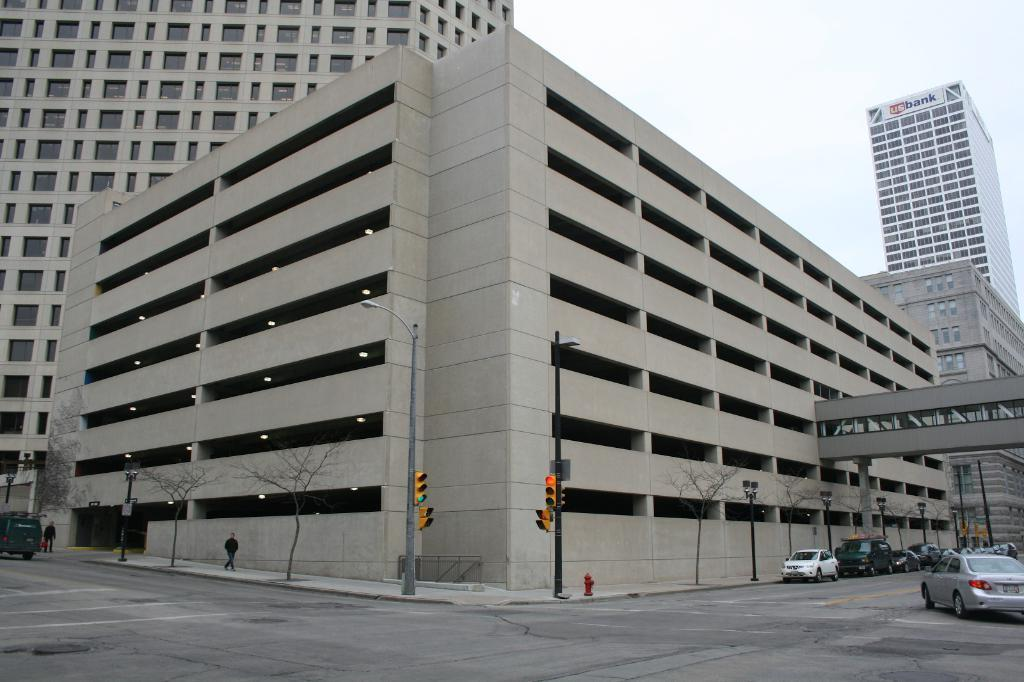What type of structures can be seen in the image? There are buildings in the image. What kind of vegetation is present in the image? Dry trees are visible in the image. What else can be seen moving in the image? A person is walking in the image. What objects are used to provide light at night in the image? Street lamps are in the image. How do vehicles know when to stop or go in the image? Traffic signals are present in the image. What part of the buildings can be seen in the image? Windows are visible in the image. What is visible at the top of the image? The sky is visible at the top of the image. What type of pocket can be seen in the image? There is no pocket present in the image. How does the person walking in the image express disgust? The image does not show any expression of disgust by the person walking. 